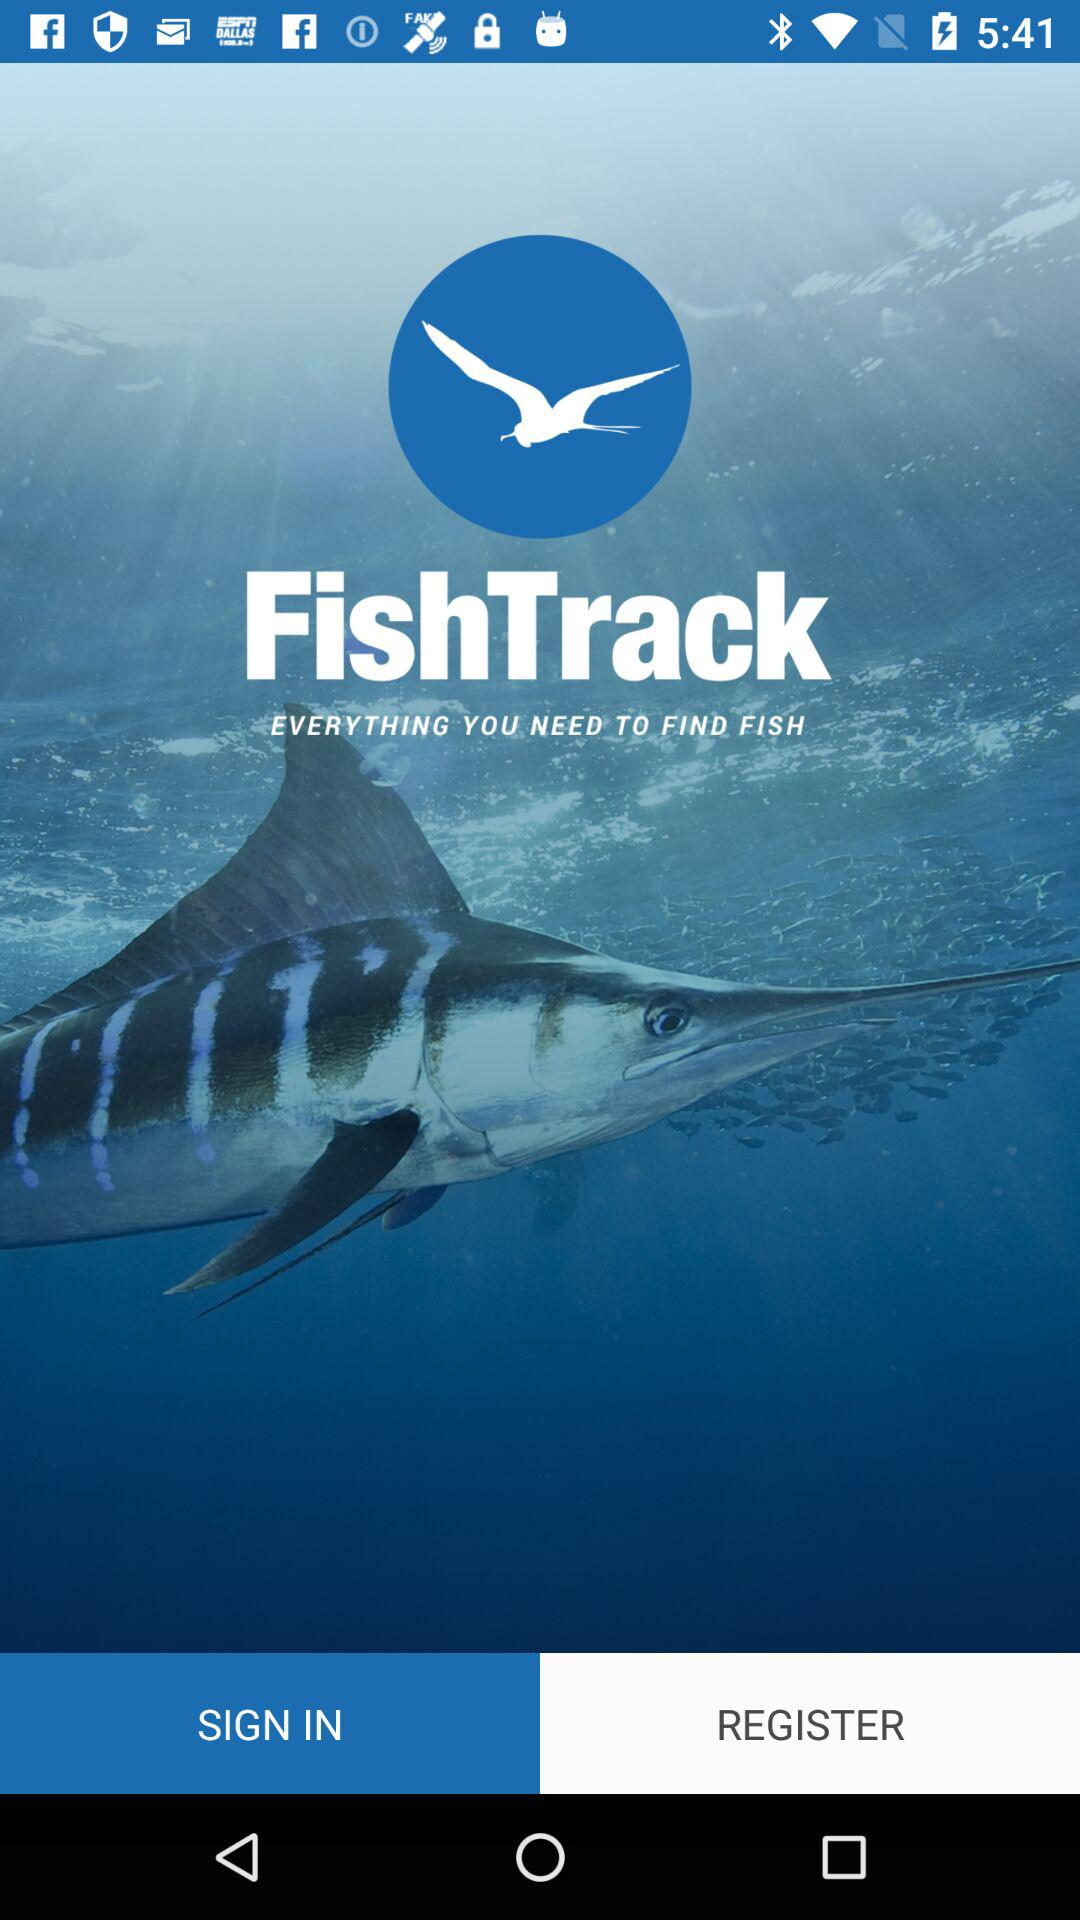What is the name of the application? The name of the application is "FishTrack". 